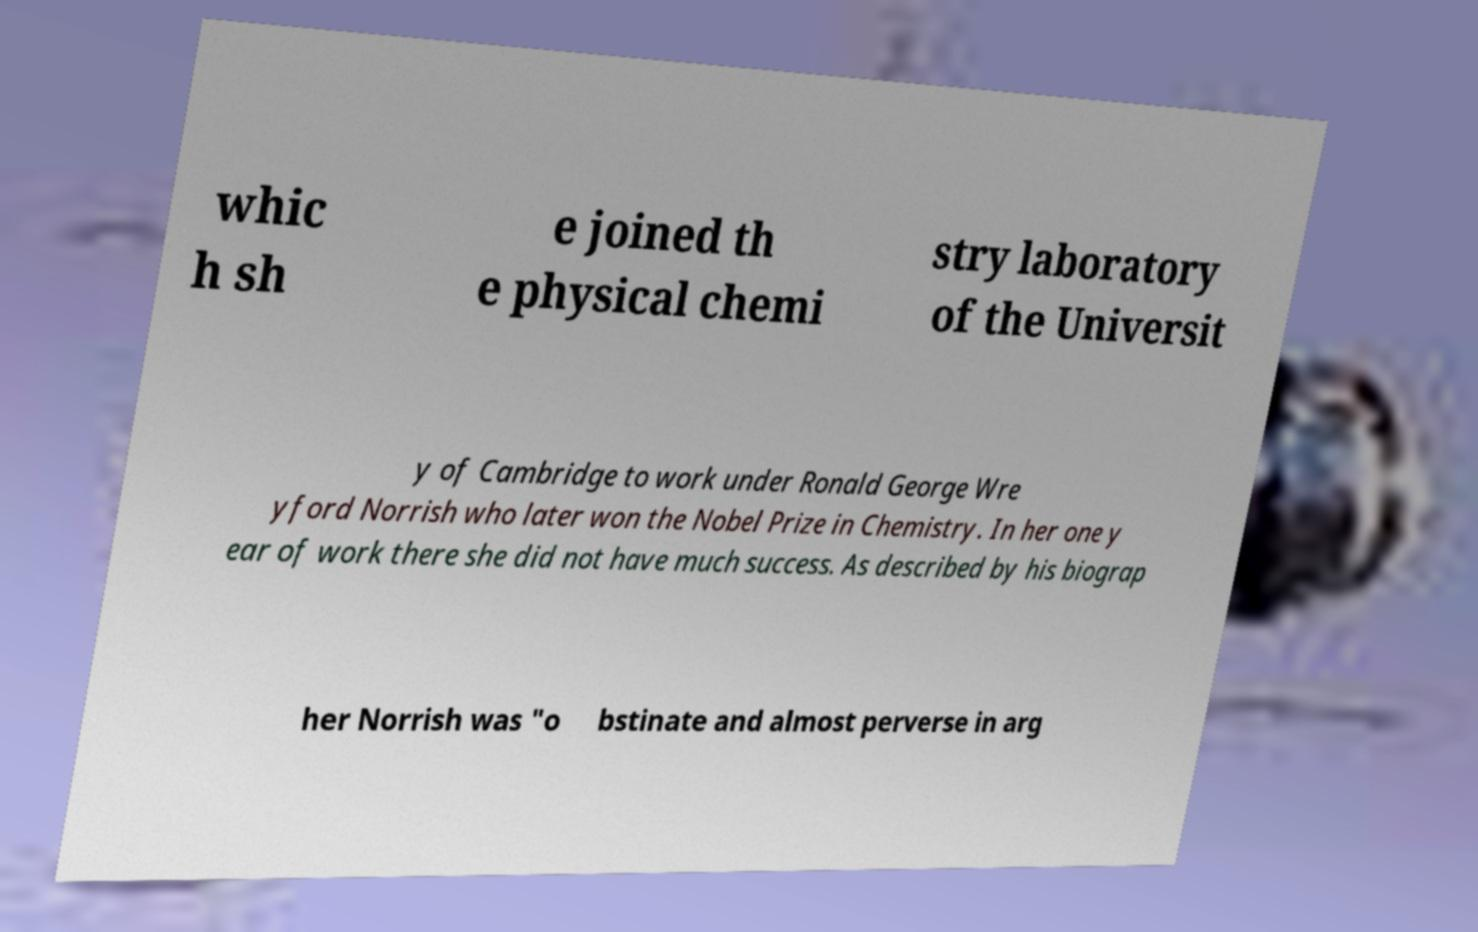For documentation purposes, I need the text within this image transcribed. Could you provide that? whic h sh e joined th e physical chemi stry laboratory of the Universit y of Cambridge to work under Ronald George Wre yford Norrish who later won the Nobel Prize in Chemistry. In her one y ear of work there she did not have much success. As described by his biograp her Norrish was "o bstinate and almost perverse in arg 